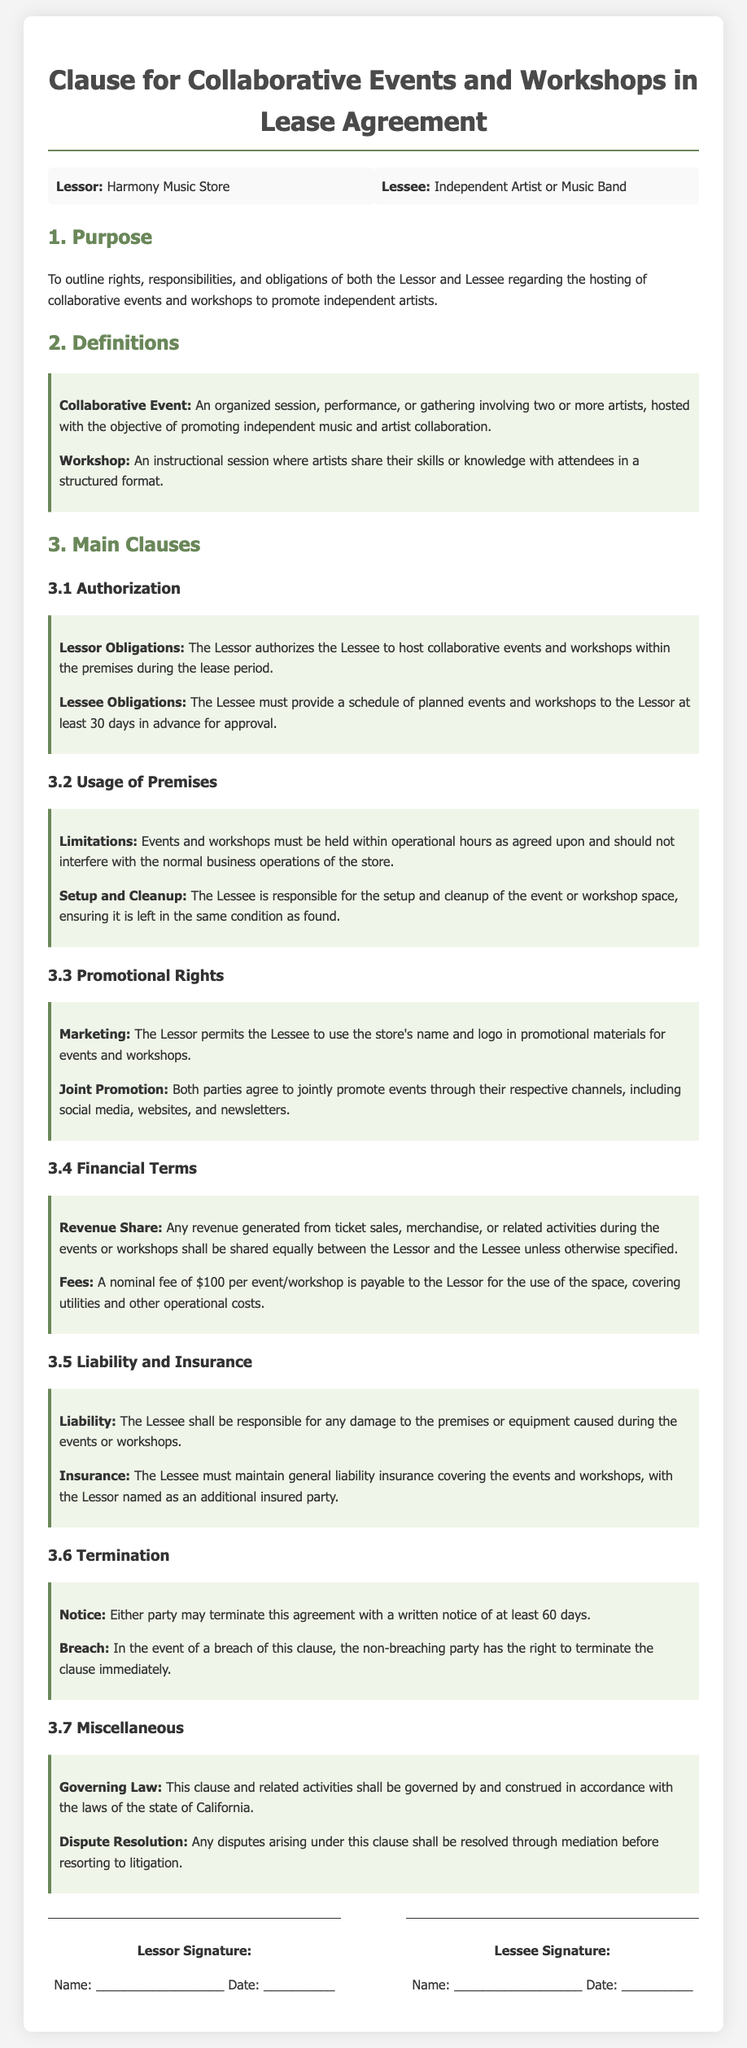What is the name of the Lessor? The Lessor is specified in the document as "Harmony Music Store."
Answer: Harmony Music Store What must the Lessee provide 30 days in advance? The document states that the Lessee must provide a schedule of planned events and workshops for approval.
Answer: Schedule of planned events and workshops What is the nominal fee for using the space per event? According to the document, there is a nominal fee of $100 per event/workshop payable to the Lessor.
Answer: $100 What is the shared revenue percentage? The document indicates that any revenue generated shall be shared equally between the Lessor and the Lessee unless specified otherwise.
Answer: Equally What is the notice period for termination of the agreement? The document specifies that either party may terminate this agreement with a written notice of at least 60 days.
Answer: 60 days Which state governs this clause? The governing law mentioned in the document is the state of California.
Answer: California What type of insurance must the Lessee maintain? The document requires the Lessee to maintain general liability insurance covering the events and workshops.
Answer: General liability insurance What is the Lessee's responsibility regarding the event space? The Lessee is responsible for the setup and cleanup of the event or workshop space, ensuring it is left in the same condition as found.
Answer: Setup and cleanup 